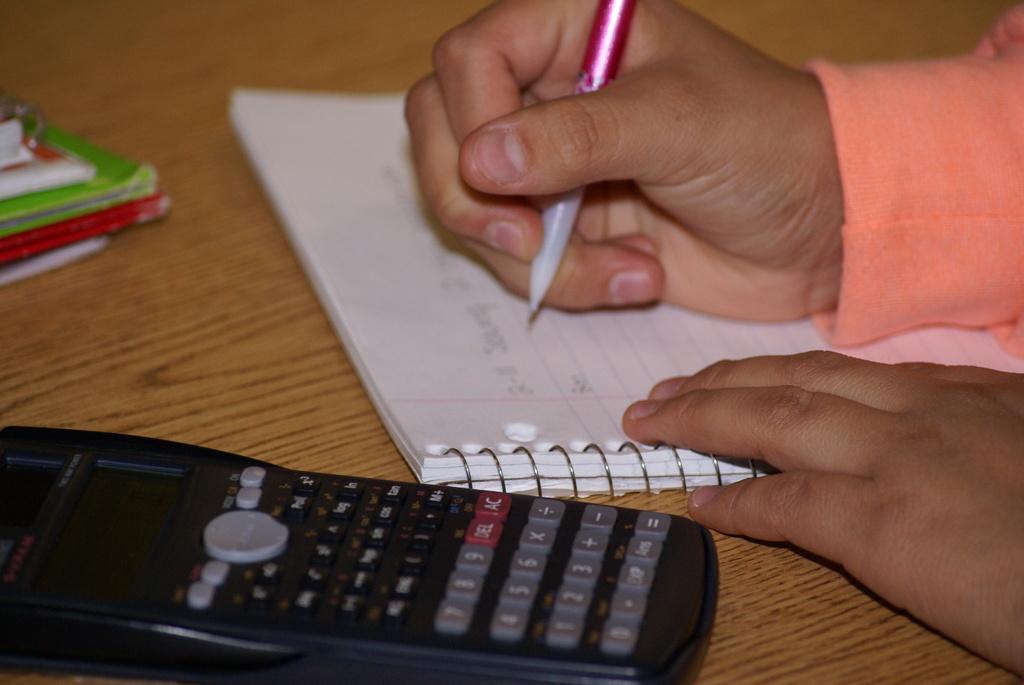What 2 letters are shown on the red button?
Offer a very short reply. Ac. 